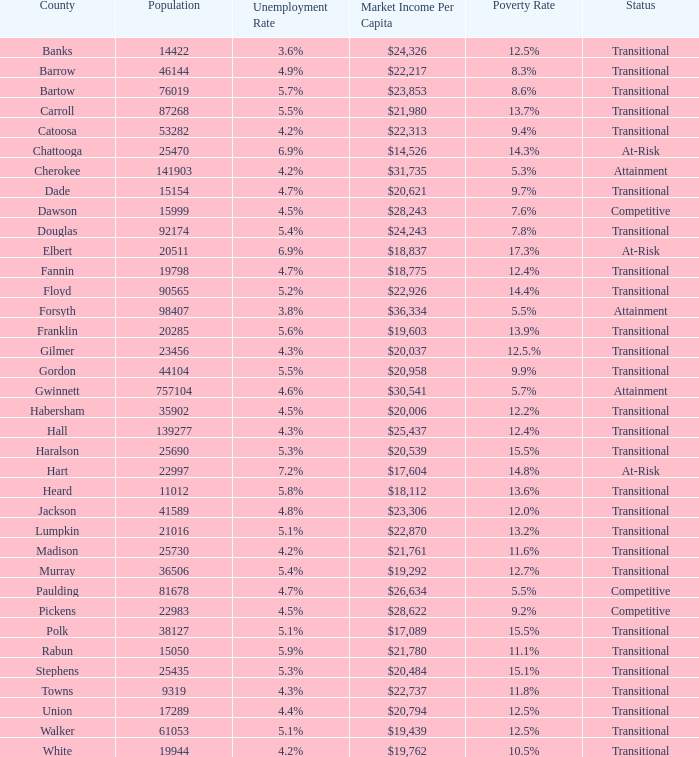6% joblessness rate? Banks. 